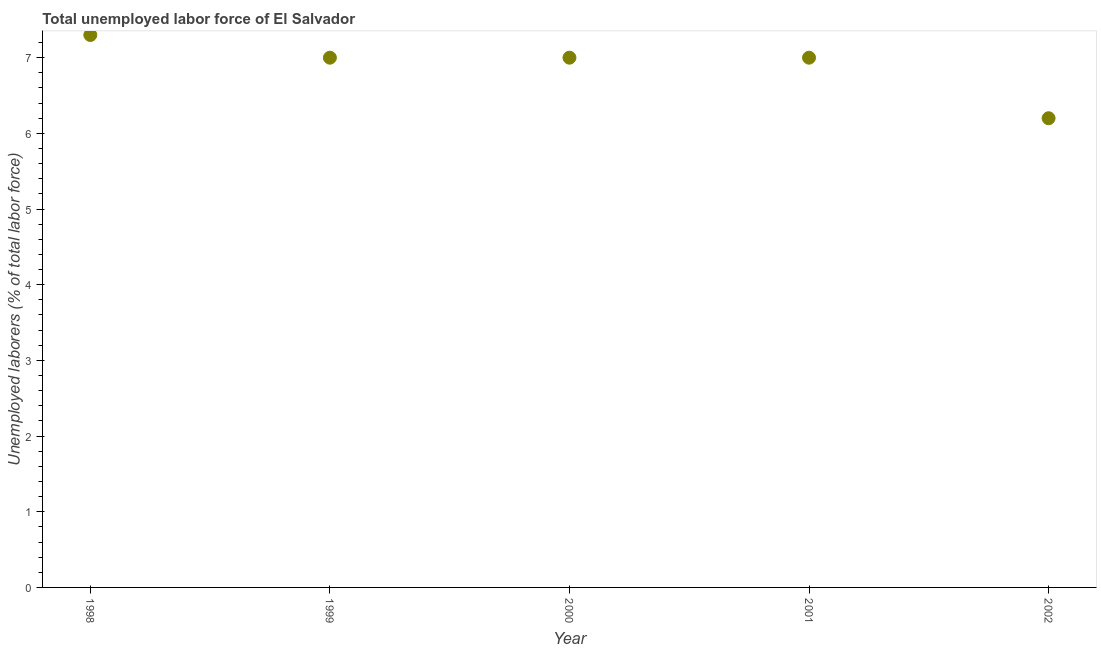What is the total unemployed labour force in 1999?
Make the answer very short. 7. Across all years, what is the maximum total unemployed labour force?
Offer a terse response. 7.3. Across all years, what is the minimum total unemployed labour force?
Make the answer very short. 6.2. In which year was the total unemployed labour force maximum?
Provide a short and direct response. 1998. In which year was the total unemployed labour force minimum?
Offer a terse response. 2002. What is the sum of the total unemployed labour force?
Keep it short and to the point. 34.5. What is the difference between the total unemployed labour force in 2000 and 2002?
Provide a succinct answer. 0.8. What is the average total unemployed labour force per year?
Make the answer very short. 6.9. What is the median total unemployed labour force?
Keep it short and to the point. 7. Do a majority of the years between 2001 and 2002 (inclusive) have total unemployed labour force greater than 2.8 %?
Offer a terse response. Yes. What is the ratio of the total unemployed labour force in 1999 to that in 2002?
Offer a very short reply. 1.13. Is the total unemployed labour force in 2001 less than that in 2002?
Give a very brief answer. No. What is the difference between the highest and the second highest total unemployed labour force?
Give a very brief answer. 0.3. What is the difference between the highest and the lowest total unemployed labour force?
Offer a very short reply. 1.1. Does the total unemployed labour force monotonically increase over the years?
Provide a succinct answer. No. How many dotlines are there?
Keep it short and to the point. 1. Does the graph contain any zero values?
Your answer should be very brief. No. Does the graph contain grids?
Your answer should be compact. No. What is the title of the graph?
Keep it short and to the point. Total unemployed labor force of El Salvador. What is the label or title of the Y-axis?
Provide a short and direct response. Unemployed laborers (% of total labor force). What is the Unemployed laborers (% of total labor force) in 1998?
Provide a succinct answer. 7.3. What is the Unemployed laborers (% of total labor force) in 1999?
Keep it short and to the point. 7. What is the Unemployed laborers (% of total labor force) in 2002?
Your answer should be very brief. 6.2. What is the difference between the Unemployed laborers (% of total labor force) in 1998 and 2002?
Make the answer very short. 1.1. What is the difference between the Unemployed laborers (% of total labor force) in 1999 and 2000?
Ensure brevity in your answer.  0. What is the difference between the Unemployed laborers (% of total labor force) in 1999 and 2002?
Your response must be concise. 0.8. What is the ratio of the Unemployed laborers (% of total labor force) in 1998 to that in 1999?
Your answer should be compact. 1.04. What is the ratio of the Unemployed laborers (% of total labor force) in 1998 to that in 2000?
Your response must be concise. 1.04. What is the ratio of the Unemployed laborers (% of total labor force) in 1998 to that in 2001?
Provide a short and direct response. 1.04. What is the ratio of the Unemployed laborers (% of total labor force) in 1998 to that in 2002?
Provide a succinct answer. 1.18. What is the ratio of the Unemployed laborers (% of total labor force) in 1999 to that in 2002?
Provide a short and direct response. 1.13. What is the ratio of the Unemployed laborers (% of total labor force) in 2000 to that in 2002?
Your answer should be very brief. 1.13. What is the ratio of the Unemployed laborers (% of total labor force) in 2001 to that in 2002?
Your answer should be compact. 1.13. 